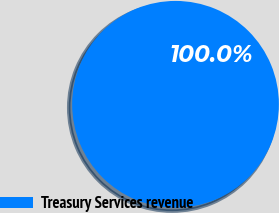Convert chart to OTSL. <chart><loc_0><loc_0><loc_500><loc_500><pie_chart><fcel>Treasury Services revenue<nl><fcel>100.0%<nl></chart> 